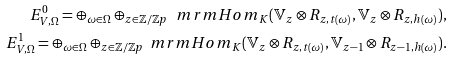Convert formula to latex. <formula><loc_0><loc_0><loc_500><loc_500>E _ { V , \Omega } ^ { 0 } = \oplus _ { \omega \in \Omega } \oplus _ { z \in \mathbb { Z / Z } p } \ m r m { H o m } _ { K } ( \mathbb { V } _ { z } \otimes R _ { z , t ( \omega ) } , \mathbb { V } _ { z } \otimes R _ { z , h ( \omega ) } ) , \\ E _ { V , \Omega } ^ { 1 } = \oplus _ { \omega \in \Omega } \oplus _ { z \in \mathbb { Z / Z } p } \ m r m { H o m } _ { K } ( \mathbb { V } _ { z } \otimes R _ { z , t ( \omega ) } , \mathbb { V } _ { z - 1 } \otimes R _ { z - 1 , h ( \omega ) } ) .</formula> 